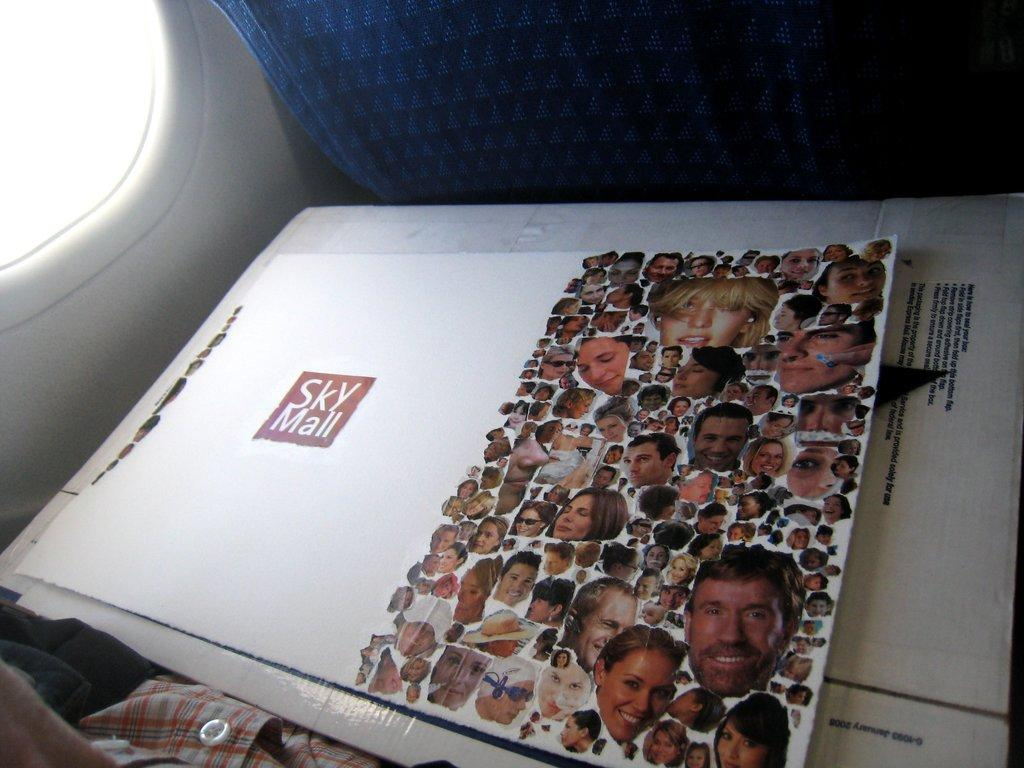What is the primary object in the image? There is a paper in the image. What can be seen in the background of the image? There is a window in the image. What type of items are visible in the image? There are clothes in the image. Can you describe any other objects in the image? There are some unspecified objects in the image. What color is the chalk used to write on the paper in the image? There is no chalk present in the image, and therefore no writing can be observed on the paper. 